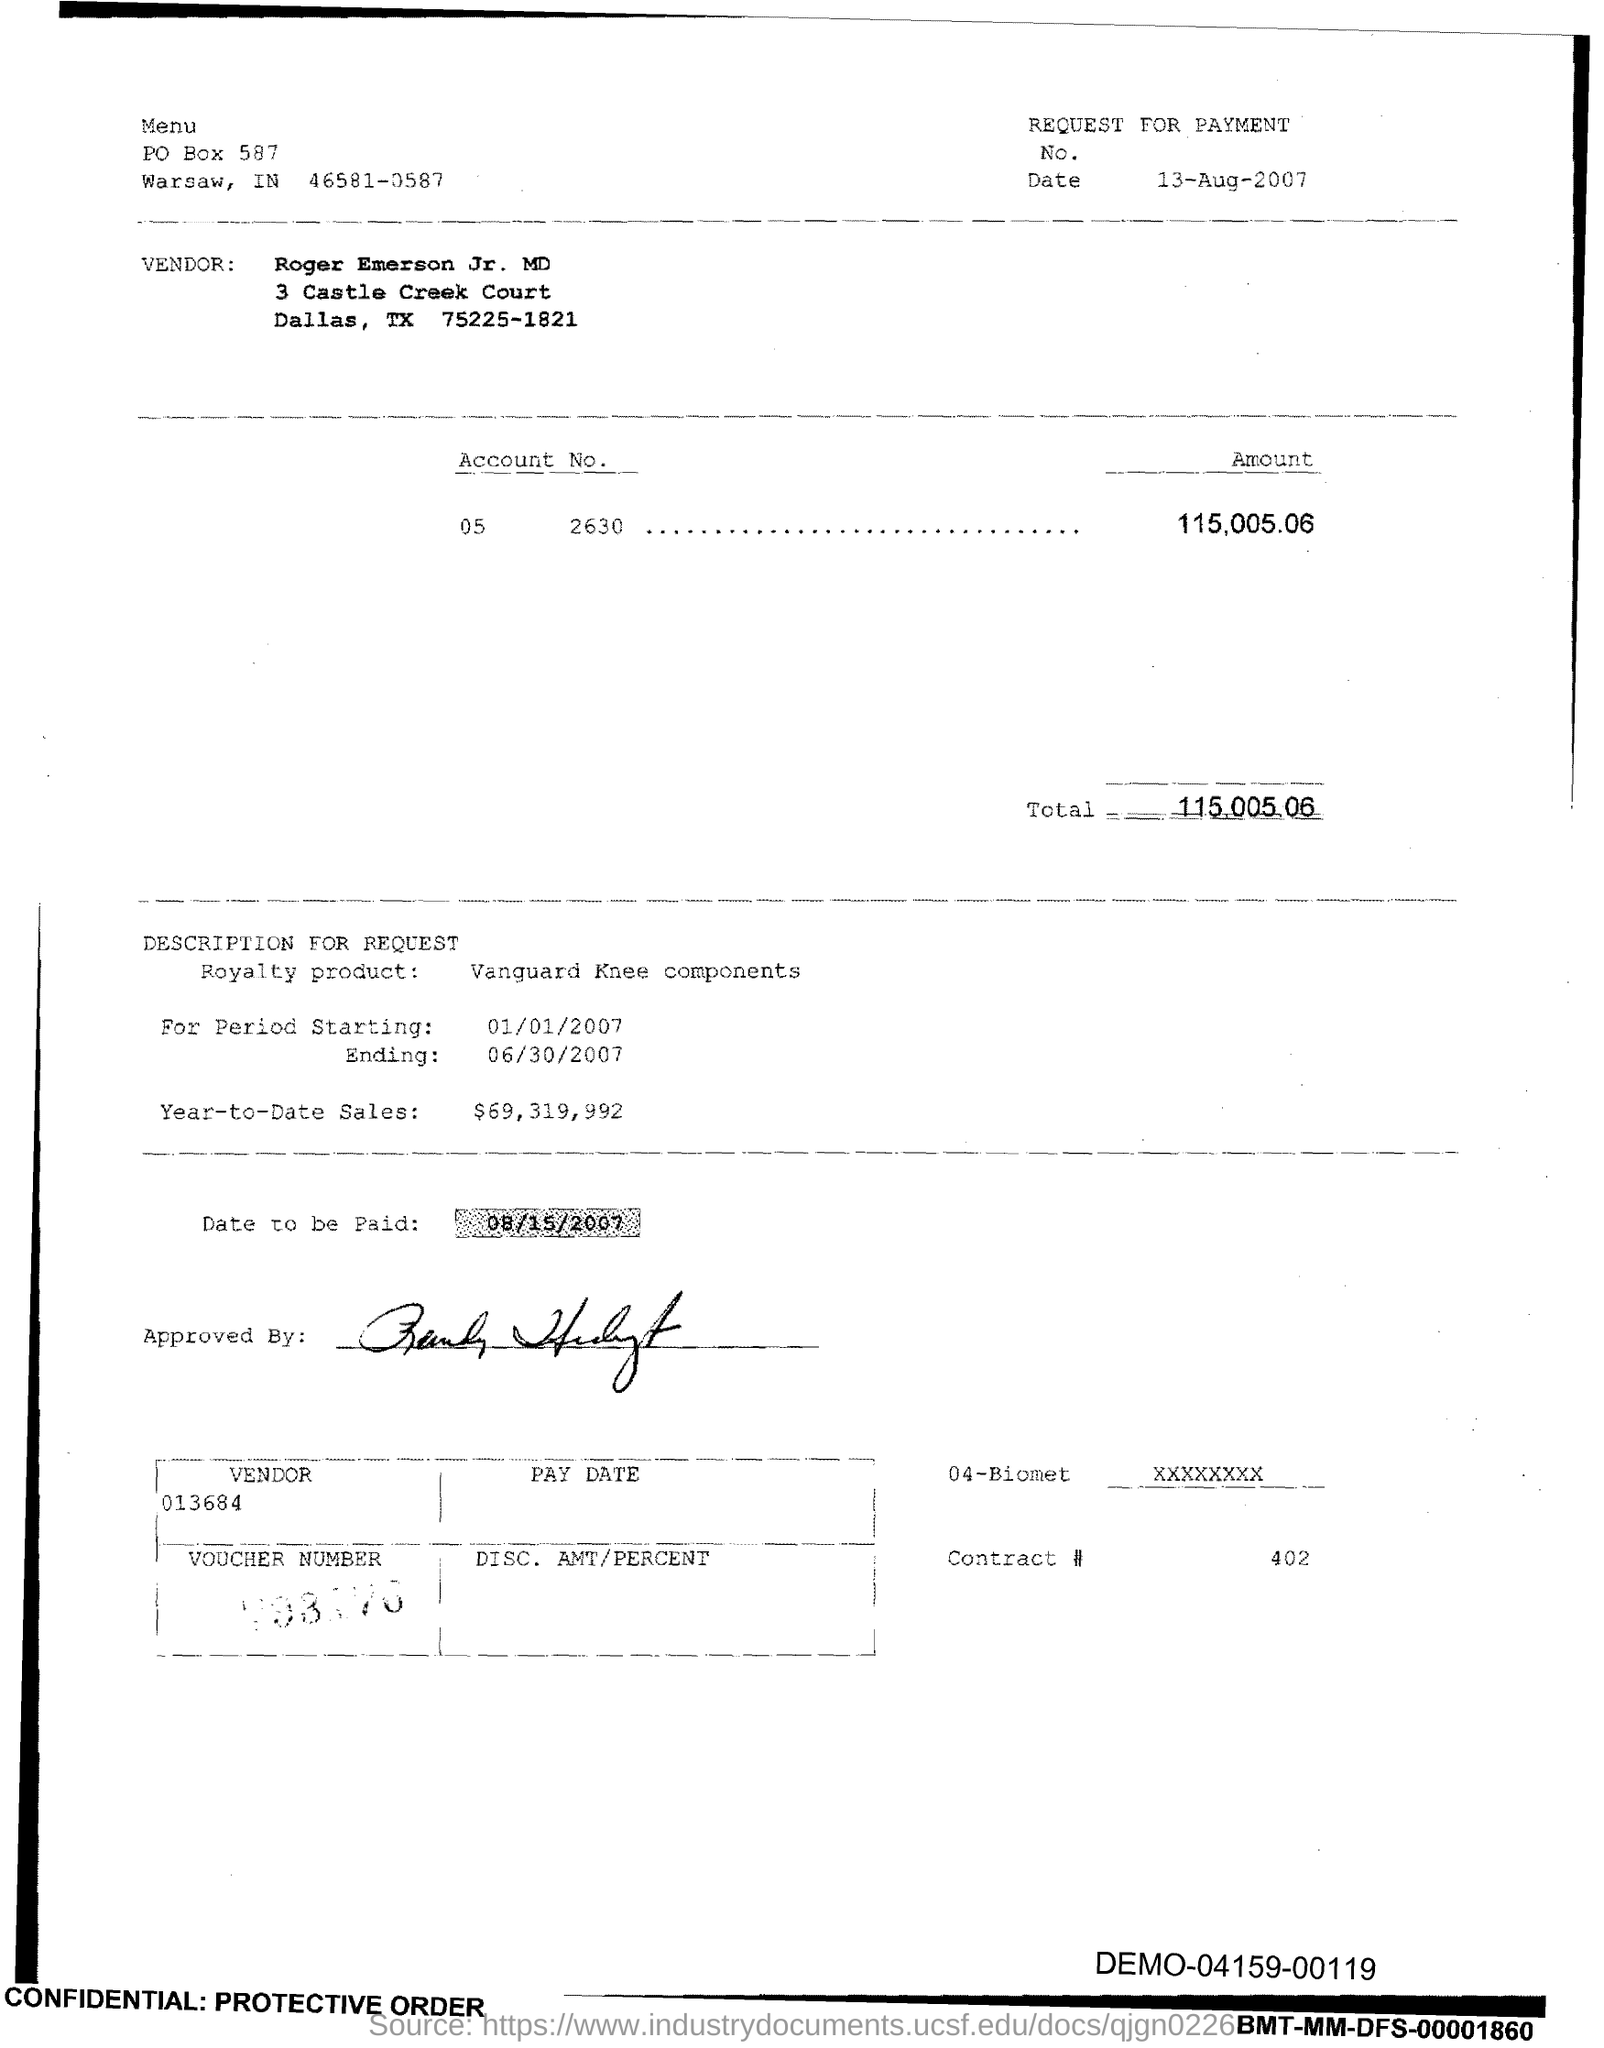Give some essential details in this illustration. As of the end of the third quarter, the year-to-date sales of the royalty product are $69,319,992. The product listed in the voucher is the royalty for Vanguard Knee components. The issued date of this voucher is August 13, 2007. The end date of the royalty period is June 30, 2007. The start date of the royalty period is January 1, 2007. 